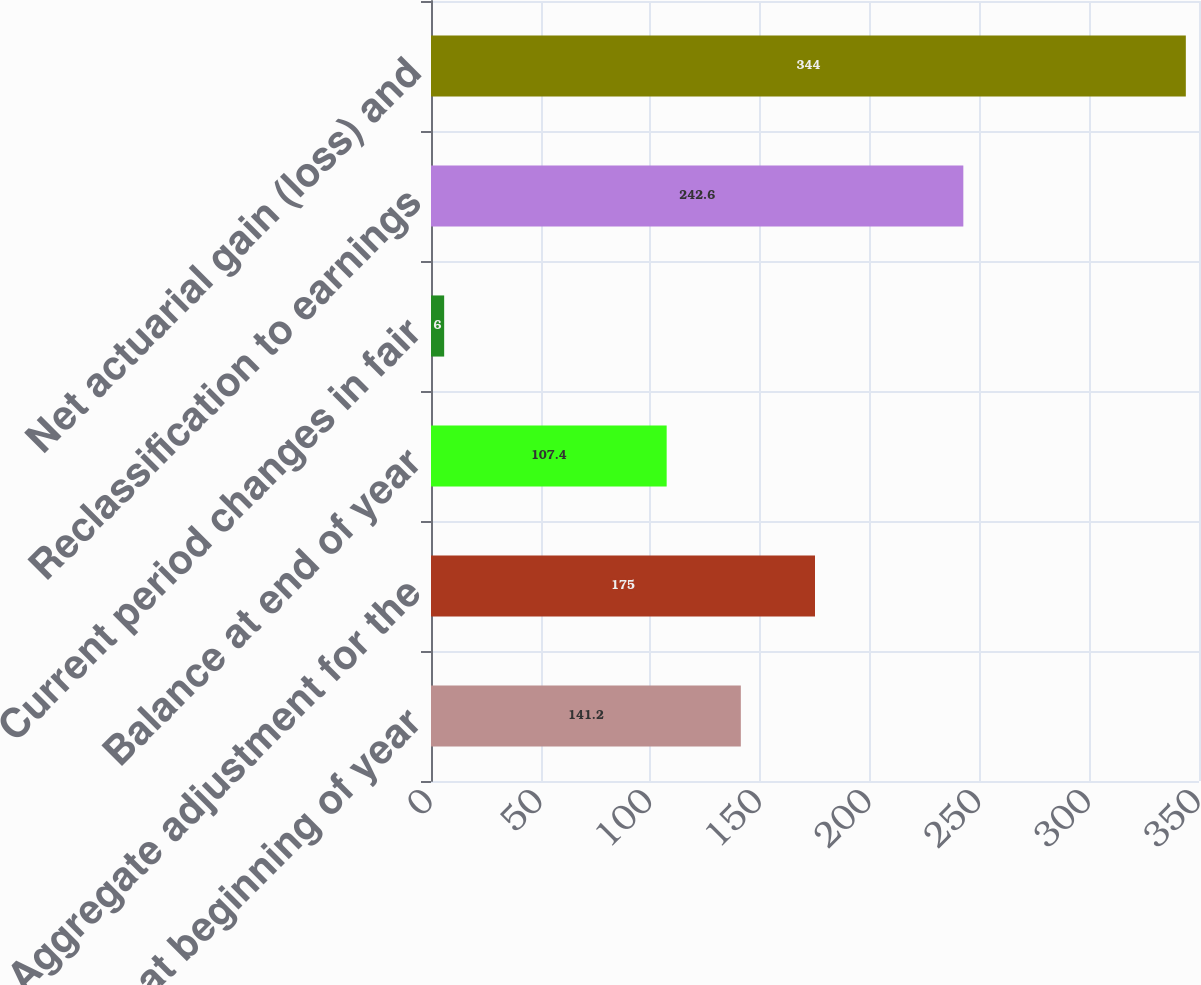Convert chart. <chart><loc_0><loc_0><loc_500><loc_500><bar_chart><fcel>Balance at beginning of year<fcel>Aggregate adjustment for the<fcel>Balance at end of year<fcel>Current period changes in fair<fcel>Reclassification to earnings<fcel>Net actuarial gain (loss) and<nl><fcel>141.2<fcel>175<fcel>107.4<fcel>6<fcel>242.6<fcel>344<nl></chart> 